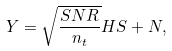Convert formula to latex. <formula><loc_0><loc_0><loc_500><loc_500>Y = \sqrt { \frac { S N R } { n _ { t } } } H S + N ,</formula> 